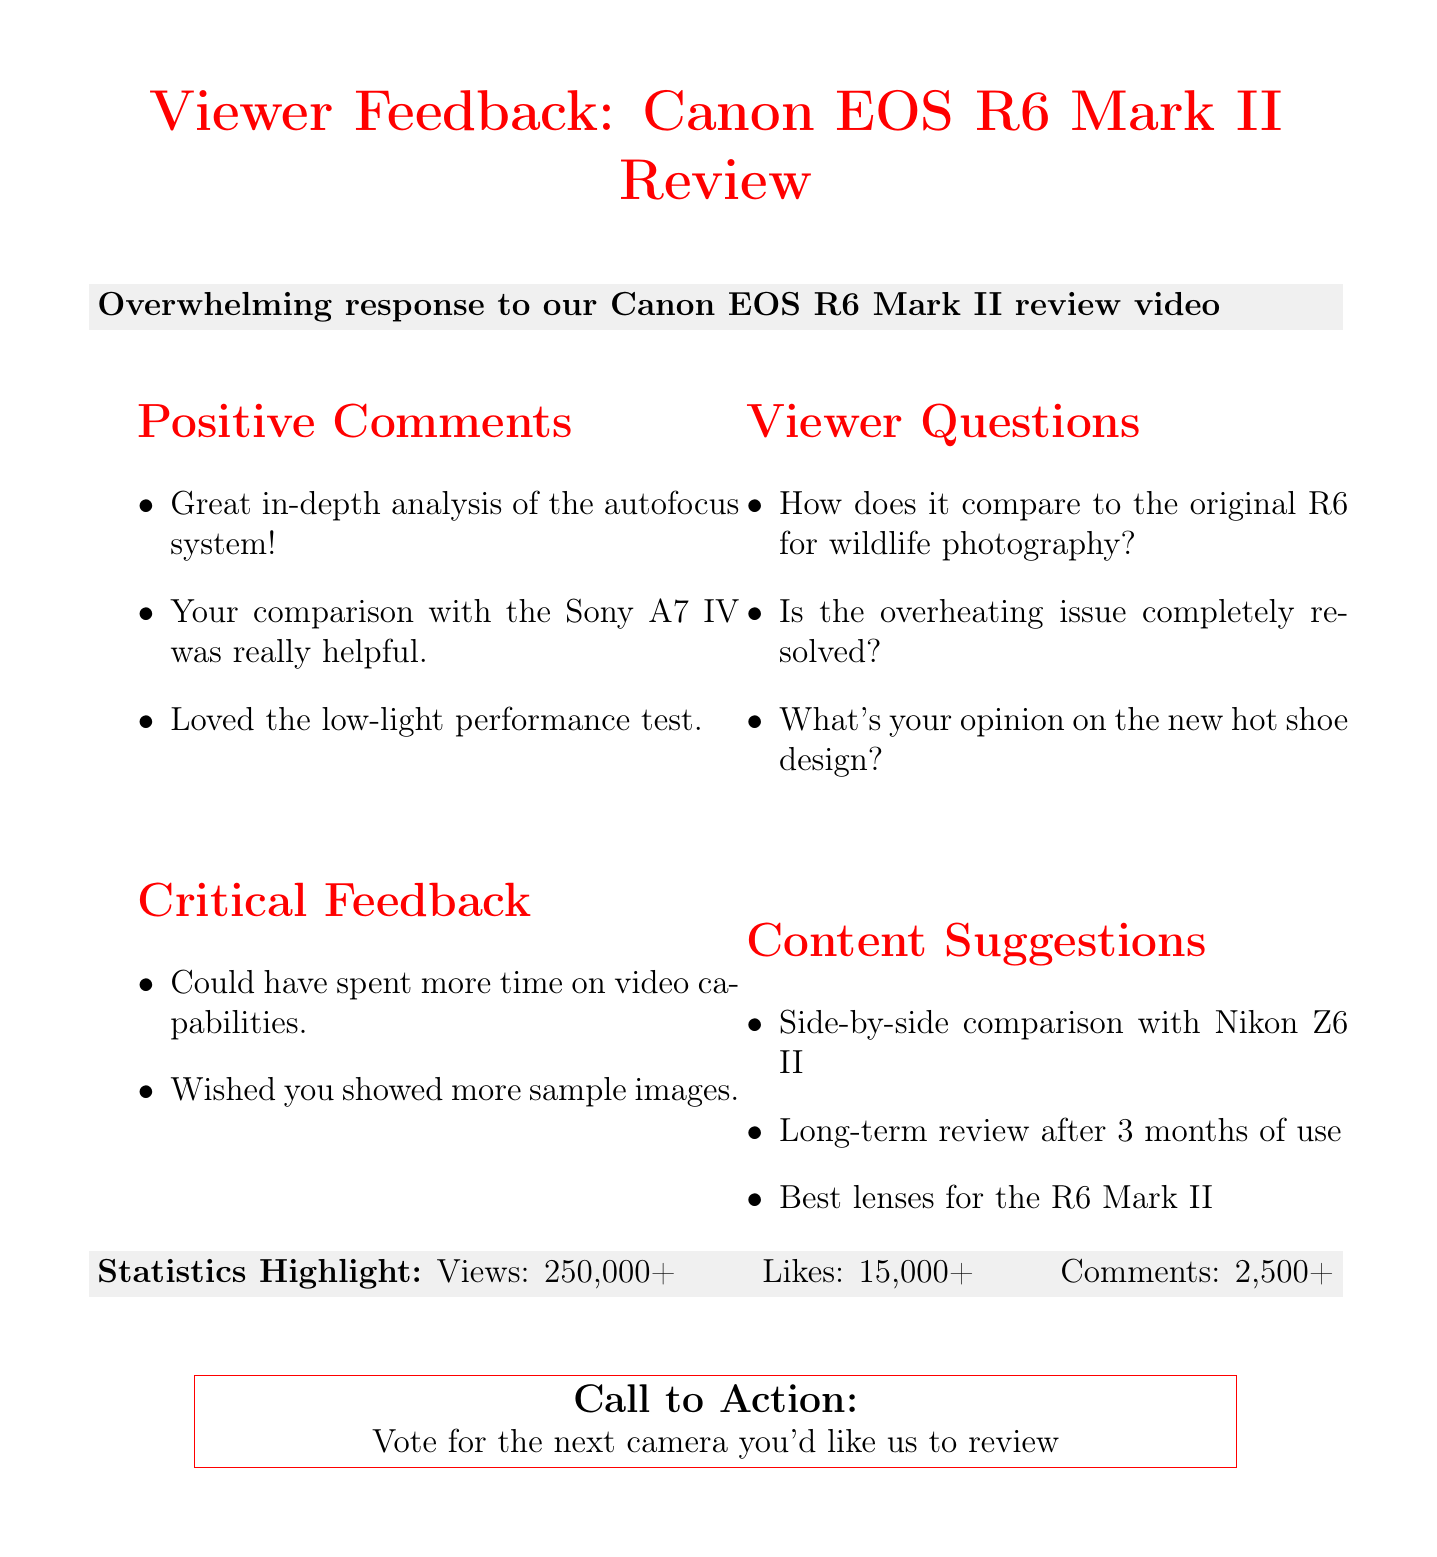What is the email subject? The email subject is explicitly stated at the beginning of the document.
Answer: Viewer Feedback: Canon EOS R6 Mark II Review How many likes did the video receive? Likes are highlighted in the statistics section, specifically stating the total number of likes.
Answer: 15,000+ What specific performance test did viewers love? This detail is included in the positive comments section, showcasing viewer appreciation.
Answer: Low-light performance test What is one critical feedback from viewers? The document lists critical feedback under a specific section dedicated to it, making it easy to retrieve.
Answer: Could have spent more time on video capabilities How many total comments were made on the video? The document provides this number in the statistics highlight, allowing for easy retrieval.
Answer: 2,500+ What was a viewer's question about overheating? This question is mentioned under the viewer questions section and is directly relevant to the camera's features.
Answer: Is the overheating issue completely resolved? What type of content do viewers suggest for the future? This includes suggestions presented under a dedicated section for viewer content ideas.
Answer: Side-by-side comparison with Nikon Z6 II How many views did the video get? Total views are listed in the statistics highlight section and are quantifiable.
Answer: 250,000+ What kind of camera comparison is suggested? This suggestion is part of the content ideas and is distinctly categorized.
Answer: Side-by-side comparison with Nikon Z6 II 